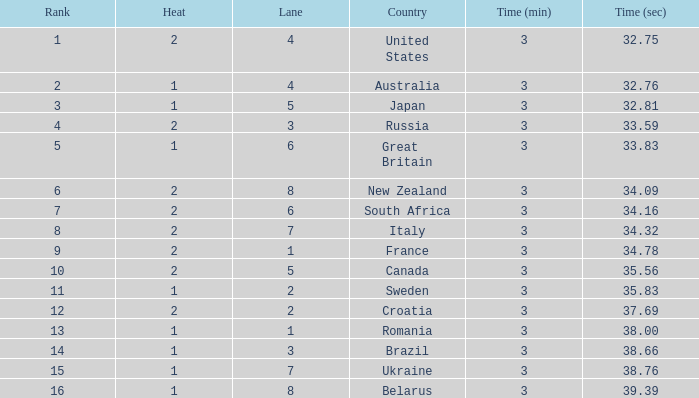Can you tell me the Time that has the Heat of 1, and the Lane of 2? 3:35.83. 